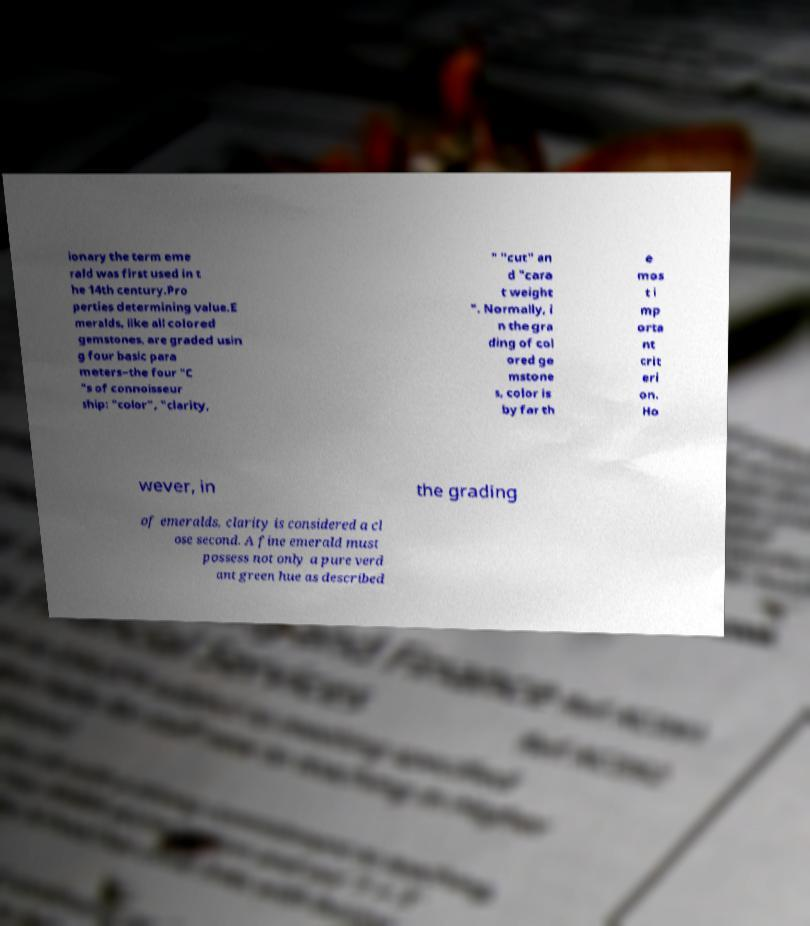There's text embedded in this image that I need extracted. Can you transcribe it verbatim? ionary the term eme rald was first used in t he 14th century.Pro perties determining value.E meralds, like all colored gemstones, are graded usin g four basic para meters–the four "C "s of connoisseur ship: "color", "clarity, " "cut" an d "cara t weight ". Normally, i n the gra ding of col ored ge mstone s, color is by far th e mos t i mp orta nt crit eri on. Ho wever, in the grading of emeralds, clarity is considered a cl ose second. A fine emerald must possess not only a pure verd ant green hue as described 